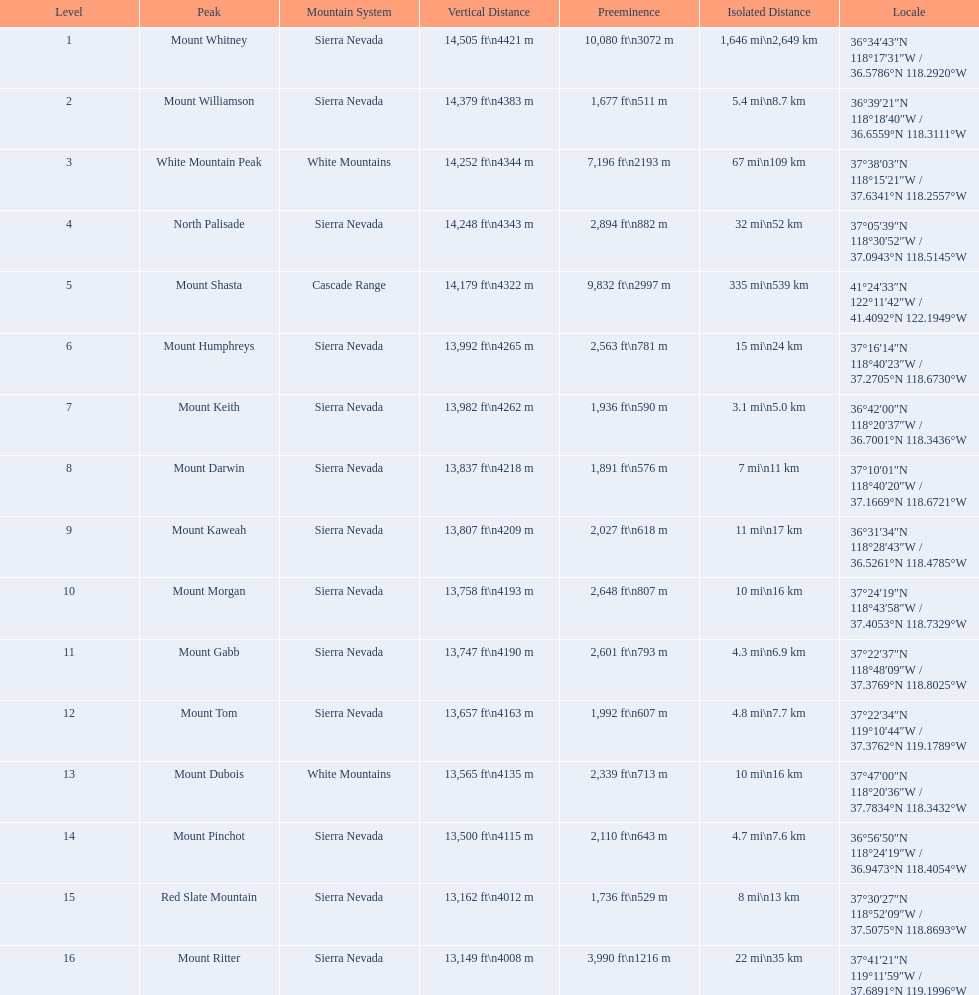Which mountain peak is the only mountain peak in the cascade range? Mount Shasta. 